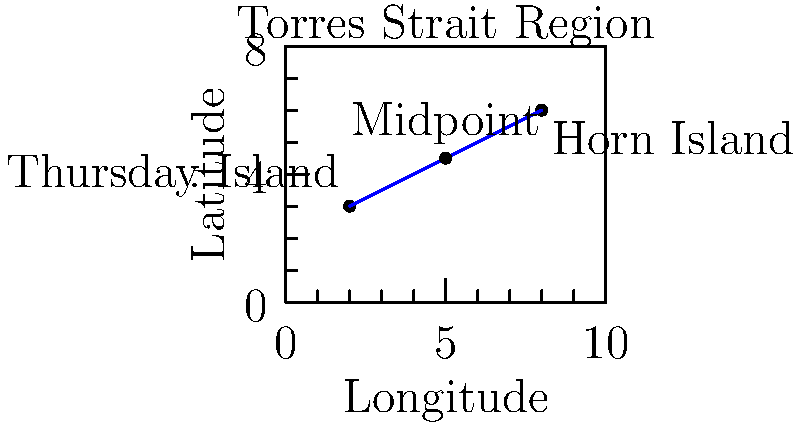On a map of the Torres Strait region, Thursday Island is located at coordinates $(2,3)$ and Horn Island is at $(8,6)$. What are the coordinates of the midpoint between these two islands? Round your answer to one decimal place. To find the midpoint of a line segment connecting two points, we use the midpoint formula:

$$ M_x = \frac{x_1 + x_2}{2}, \quad M_y = \frac{y_1 + y_2}{2} $$

Where $(x_1,y_1)$ are the coordinates of the first point and $(x_2,y_2)$ are the coordinates of the second point.

For Thursday Island: $(x_1,y_1) = (2,3)$
For Horn Island: $(x_2,y_2) = (8,6)$

Calculating the x-coordinate of the midpoint:
$$ M_x = \frac{2 + 8}{2} = \frac{10}{2} = 5 $$

Calculating the y-coordinate of the midpoint:
$$ M_y = \frac{3 + 6}{2} = \frac{9}{2} = 4.5 $$

Therefore, the coordinates of the midpoint are $(5, 4.5)$.

Rounding to one decimal place: $(5.0, 4.5)$
Answer: $(5.0, 4.5)$ 